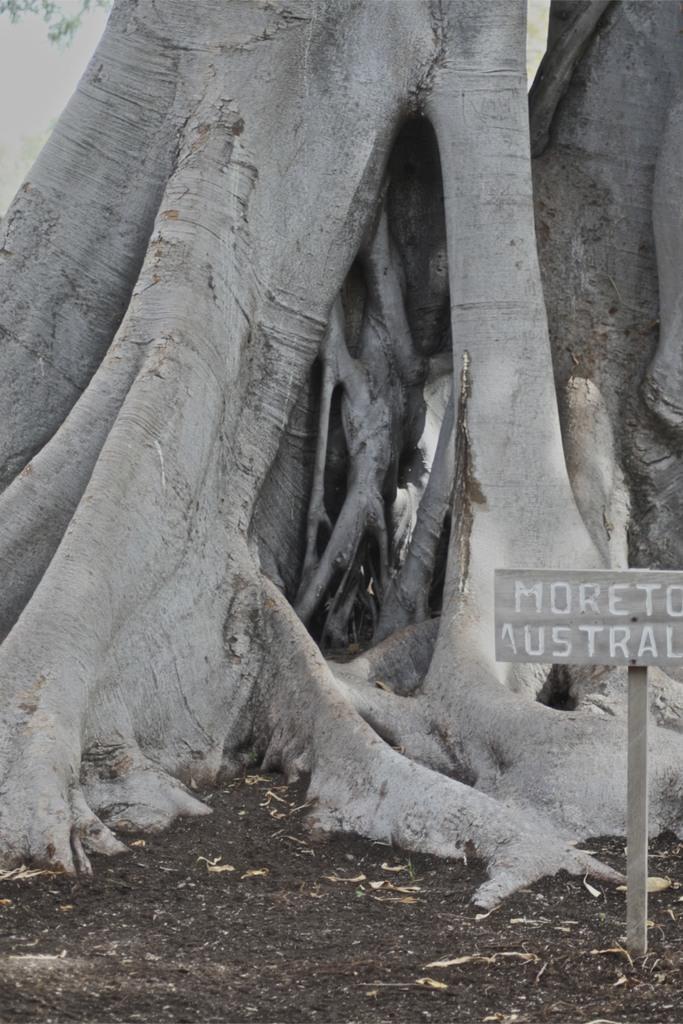In one or two sentences, can you explain what this image depicts? In this picture we can see a tree, on the right side there is a board, we can see some text on the board, at the bottom there are some leaves and soil. 